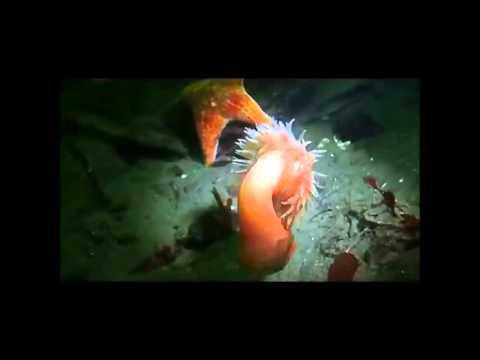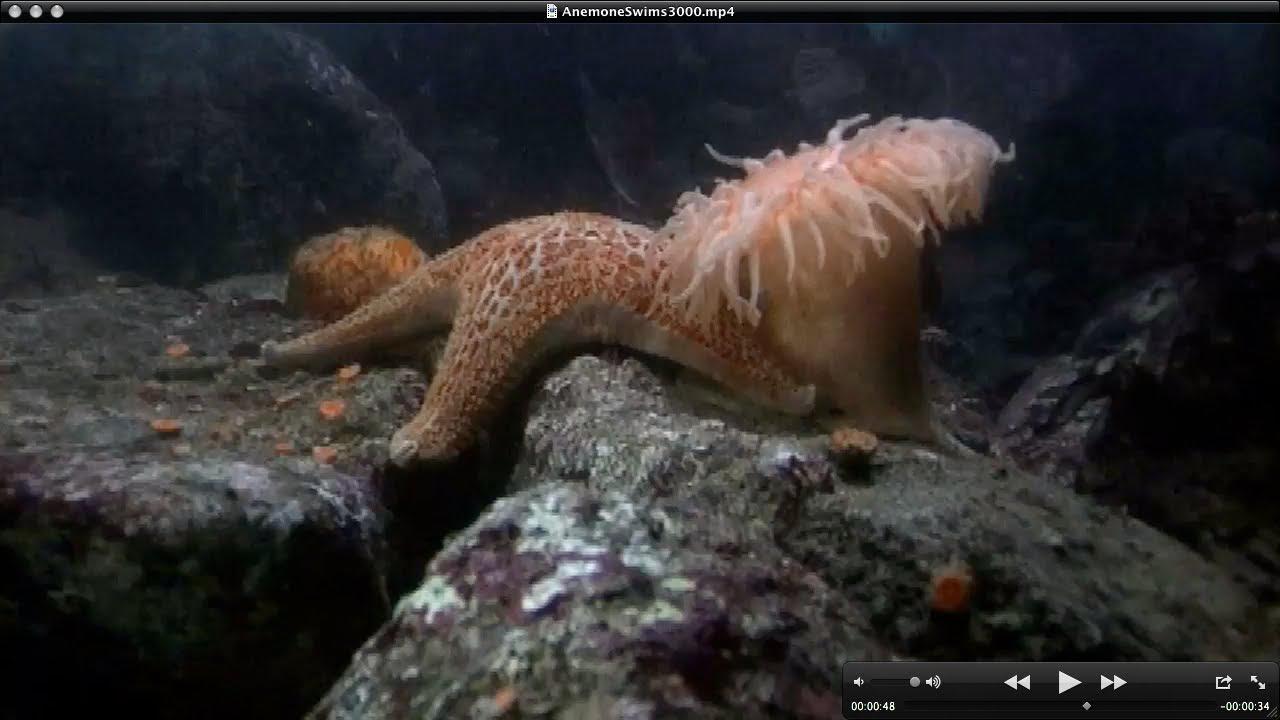The first image is the image on the left, the second image is the image on the right. Analyze the images presented: Is the assertion "In one image in each pair there is a starfish to the left of an anenome." valid? Answer yes or no. Yes. The first image is the image on the left, the second image is the image on the right. Considering the images on both sides, is "At least one image shows fish swimming around a sea anemone." valid? Answer yes or no. No. The first image is the image on the left, the second image is the image on the right. Evaluate the accuracy of this statement regarding the images: "The anemone in the left image is orange.". Is it true? Answer yes or no. Yes. The first image is the image on the left, the second image is the image on the right. Evaluate the accuracy of this statement regarding the images: "One of the two images shows more than one of the same species of free-swimming fish.". Is it true? Answer yes or no. No. 